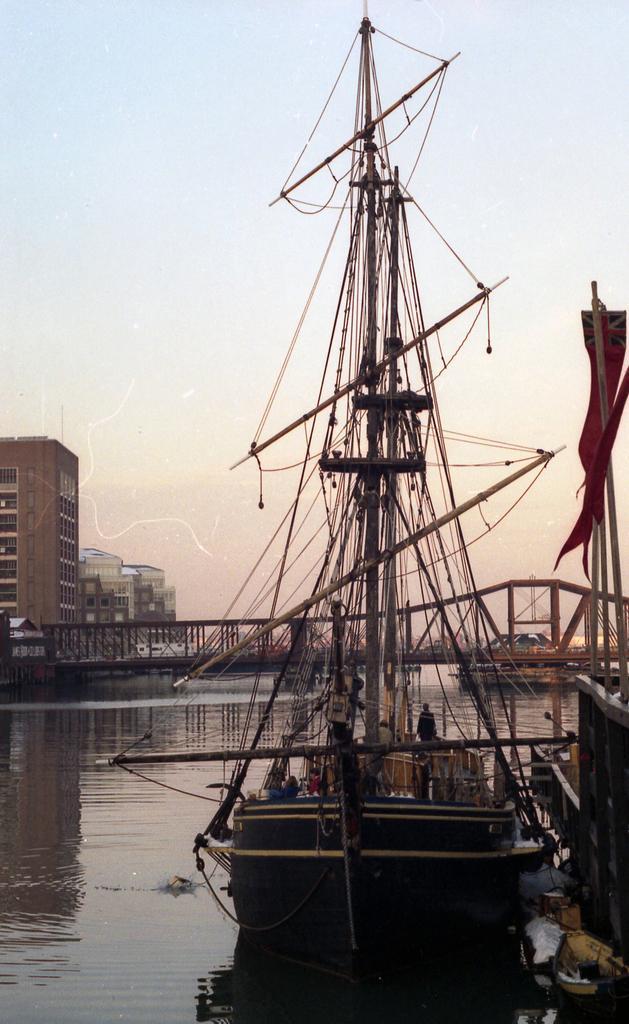How would you summarize this image in a sentence or two? The image might be taken in a shipyard. In the foreground of the picture there is a boat and dock. In the middle of the picture there are buildings and a bridge. In this picture there is a water body. In the background we can see sky. 